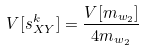<formula> <loc_0><loc_0><loc_500><loc_500>V [ s _ { X Y } ^ { k } ] = \frac { V [ m _ { w _ { 2 } } ] } { 4 m _ { w _ { 2 } } }</formula> 